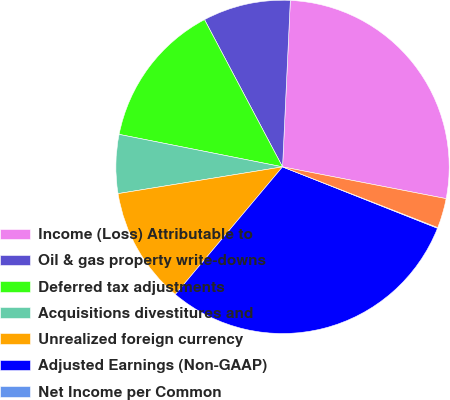Convert chart to OTSL. <chart><loc_0><loc_0><loc_500><loc_500><pie_chart><fcel>Income (Loss) Attributable to<fcel>Oil & gas property write-downs<fcel>Deferred tax adjustments<fcel>Acquisitions divestitures and<fcel>Unrealized foreign currency<fcel>Adjusted Earnings (Non-GAAP)<fcel>Net Income per Common<fcel>Adjusted Earnings Per<nl><fcel>27.31%<fcel>8.5%<fcel>14.12%<fcel>5.69%<fcel>11.31%<fcel>30.12%<fcel>0.07%<fcel>2.88%<nl></chart> 